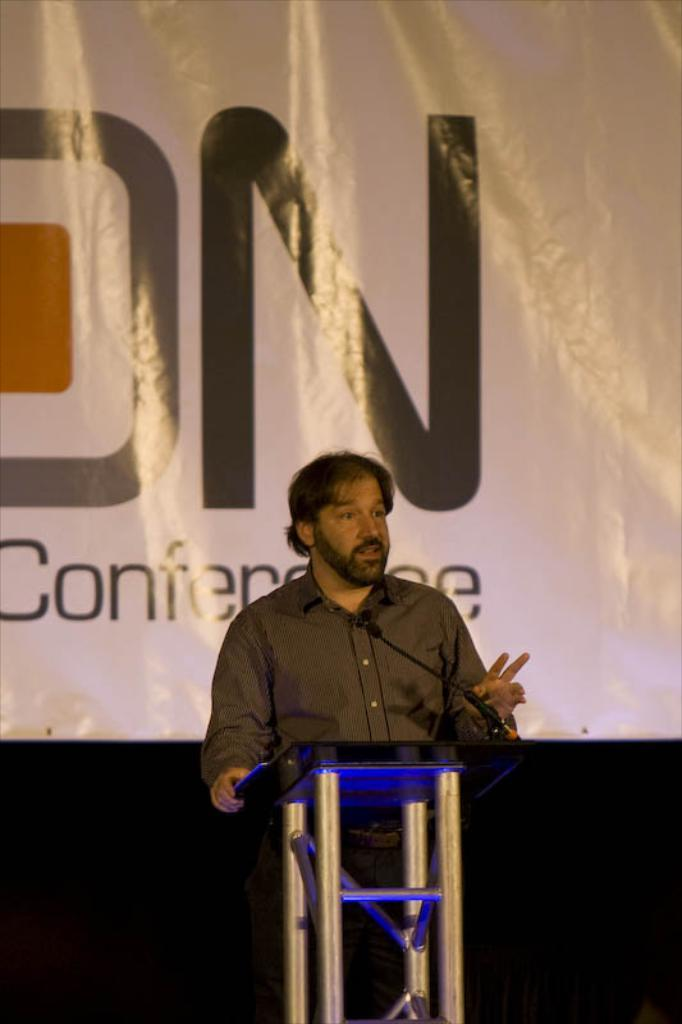Who is the main subject in the image? There is a man in the middle of the image. What is the man wearing? The man is wearing a shirt. What is the man doing in the image? The man is speaking. What is in front of the man? There is a podium and a microphone in front of the man. What can be seen in the background of the image? There is a poster in the background of the image. What is written on the poster? There is text visible on the poster. What type of sound can be heard coming from the man in the image? There is no sound present in the image, as it is a still photograph. What is the man reading from in the image? There is no book or document visible in the image, so it cannot be determined what the man might be reading from. 